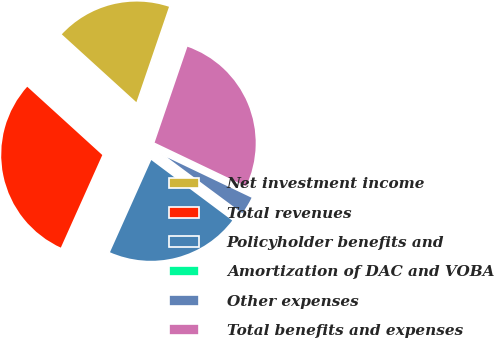Convert chart to OTSL. <chart><loc_0><loc_0><loc_500><loc_500><pie_chart><fcel>Net investment income<fcel>Total revenues<fcel>Policyholder benefits and<fcel>Amortization of DAC and VOBA<fcel>Other expenses<fcel>Total benefits and expenses<nl><fcel>18.5%<fcel>30.05%<fcel>21.49%<fcel>0.06%<fcel>3.06%<fcel>26.85%<nl></chart> 